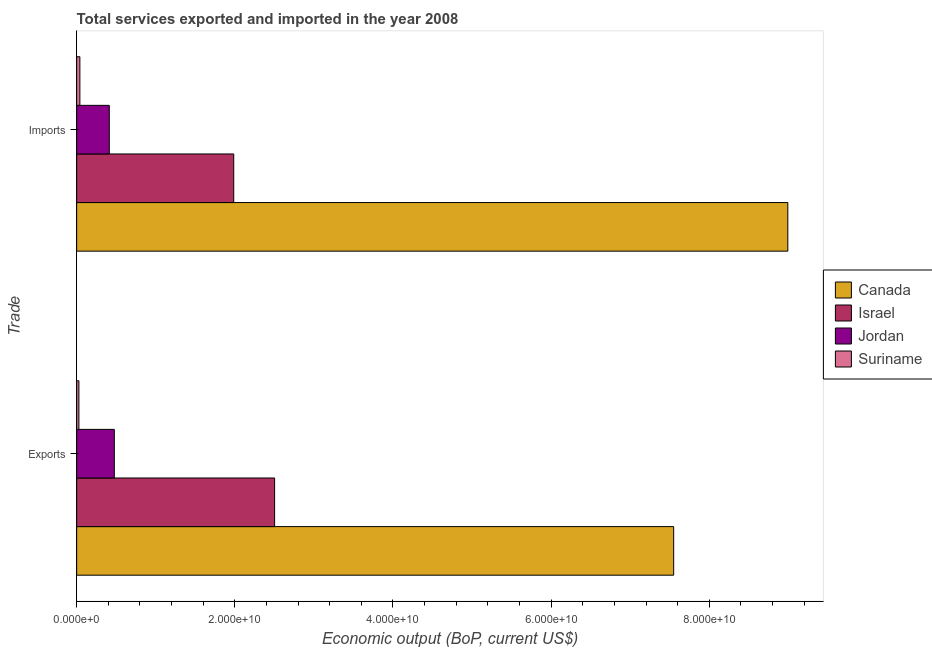How many groups of bars are there?
Provide a succinct answer. 2. Are the number of bars per tick equal to the number of legend labels?
Provide a short and direct response. Yes. Are the number of bars on each tick of the Y-axis equal?
Your response must be concise. Yes. How many bars are there on the 2nd tick from the bottom?
Your answer should be very brief. 4. What is the label of the 2nd group of bars from the top?
Your answer should be compact. Exports. What is the amount of service imports in Israel?
Provide a succinct answer. 1.99e+1. Across all countries, what is the maximum amount of service imports?
Give a very brief answer. 8.99e+1. Across all countries, what is the minimum amount of service exports?
Ensure brevity in your answer.  2.84e+08. In which country was the amount of service exports maximum?
Your answer should be very brief. Canada. In which country was the amount of service exports minimum?
Give a very brief answer. Suriname. What is the total amount of service imports in the graph?
Give a very brief answer. 1.14e+11. What is the difference between the amount of service exports in Israel and that in Jordan?
Offer a terse response. 2.03e+1. What is the difference between the amount of service imports in Canada and the amount of service exports in Jordan?
Make the answer very short. 8.52e+1. What is the average amount of service imports per country?
Provide a succinct answer. 2.86e+1. What is the difference between the amount of service exports and amount of service imports in Suriname?
Ensure brevity in your answer.  -1.23e+08. In how many countries, is the amount of service exports greater than 88000000000 US$?
Ensure brevity in your answer.  0. What is the ratio of the amount of service imports in Israel to that in Suriname?
Your answer should be compact. 48.78. What does the 3rd bar from the bottom in Exports represents?
Provide a succinct answer. Jordan. Are all the bars in the graph horizontal?
Give a very brief answer. Yes. How many countries are there in the graph?
Your answer should be very brief. 4. Are the values on the major ticks of X-axis written in scientific E-notation?
Your answer should be compact. Yes. What is the title of the graph?
Offer a very short reply. Total services exported and imported in the year 2008. What is the label or title of the X-axis?
Your response must be concise. Economic output (BoP, current US$). What is the label or title of the Y-axis?
Give a very brief answer. Trade. What is the Economic output (BoP, current US$) in Canada in Exports?
Your answer should be compact. 7.55e+1. What is the Economic output (BoP, current US$) in Israel in Exports?
Your answer should be compact. 2.50e+1. What is the Economic output (BoP, current US$) in Jordan in Exports?
Your answer should be very brief. 4.76e+09. What is the Economic output (BoP, current US$) in Suriname in Exports?
Ensure brevity in your answer.  2.84e+08. What is the Economic output (BoP, current US$) in Canada in Imports?
Offer a terse response. 8.99e+1. What is the Economic output (BoP, current US$) of Israel in Imports?
Your answer should be compact. 1.99e+1. What is the Economic output (BoP, current US$) in Jordan in Imports?
Your response must be concise. 4.13e+09. What is the Economic output (BoP, current US$) of Suriname in Imports?
Make the answer very short. 4.07e+08. Across all Trade, what is the maximum Economic output (BoP, current US$) of Canada?
Your answer should be compact. 8.99e+1. Across all Trade, what is the maximum Economic output (BoP, current US$) of Israel?
Ensure brevity in your answer.  2.50e+1. Across all Trade, what is the maximum Economic output (BoP, current US$) in Jordan?
Your response must be concise. 4.76e+09. Across all Trade, what is the maximum Economic output (BoP, current US$) of Suriname?
Provide a short and direct response. 4.07e+08. Across all Trade, what is the minimum Economic output (BoP, current US$) of Canada?
Provide a succinct answer. 7.55e+1. Across all Trade, what is the minimum Economic output (BoP, current US$) in Israel?
Offer a terse response. 1.99e+1. Across all Trade, what is the minimum Economic output (BoP, current US$) of Jordan?
Offer a terse response. 4.13e+09. Across all Trade, what is the minimum Economic output (BoP, current US$) of Suriname?
Make the answer very short. 2.84e+08. What is the total Economic output (BoP, current US$) in Canada in the graph?
Ensure brevity in your answer.  1.65e+11. What is the total Economic output (BoP, current US$) of Israel in the graph?
Keep it short and to the point. 4.49e+1. What is the total Economic output (BoP, current US$) in Jordan in the graph?
Give a very brief answer. 8.89e+09. What is the total Economic output (BoP, current US$) in Suriname in the graph?
Provide a short and direct response. 6.91e+08. What is the difference between the Economic output (BoP, current US$) of Canada in Exports and that in Imports?
Keep it short and to the point. -1.44e+1. What is the difference between the Economic output (BoP, current US$) in Israel in Exports and that in Imports?
Ensure brevity in your answer.  5.17e+09. What is the difference between the Economic output (BoP, current US$) in Jordan in Exports and that in Imports?
Your response must be concise. 6.35e+08. What is the difference between the Economic output (BoP, current US$) in Suriname in Exports and that in Imports?
Make the answer very short. -1.23e+08. What is the difference between the Economic output (BoP, current US$) in Canada in Exports and the Economic output (BoP, current US$) in Israel in Imports?
Keep it short and to the point. 5.56e+1. What is the difference between the Economic output (BoP, current US$) of Canada in Exports and the Economic output (BoP, current US$) of Jordan in Imports?
Offer a very short reply. 7.14e+1. What is the difference between the Economic output (BoP, current US$) in Canada in Exports and the Economic output (BoP, current US$) in Suriname in Imports?
Give a very brief answer. 7.51e+1. What is the difference between the Economic output (BoP, current US$) of Israel in Exports and the Economic output (BoP, current US$) of Jordan in Imports?
Give a very brief answer. 2.09e+1. What is the difference between the Economic output (BoP, current US$) of Israel in Exports and the Economic output (BoP, current US$) of Suriname in Imports?
Ensure brevity in your answer.  2.46e+1. What is the difference between the Economic output (BoP, current US$) in Jordan in Exports and the Economic output (BoP, current US$) in Suriname in Imports?
Your answer should be very brief. 4.35e+09. What is the average Economic output (BoP, current US$) in Canada per Trade?
Provide a short and direct response. 8.27e+1. What is the average Economic output (BoP, current US$) in Israel per Trade?
Your answer should be compact. 2.24e+1. What is the average Economic output (BoP, current US$) in Jordan per Trade?
Provide a short and direct response. 4.44e+09. What is the average Economic output (BoP, current US$) in Suriname per Trade?
Your answer should be compact. 3.46e+08. What is the difference between the Economic output (BoP, current US$) in Canada and Economic output (BoP, current US$) in Israel in Exports?
Make the answer very short. 5.05e+1. What is the difference between the Economic output (BoP, current US$) of Canada and Economic output (BoP, current US$) of Jordan in Exports?
Offer a very short reply. 7.07e+1. What is the difference between the Economic output (BoP, current US$) of Canada and Economic output (BoP, current US$) of Suriname in Exports?
Keep it short and to the point. 7.52e+1. What is the difference between the Economic output (BoP, current US$) of Israel and Economic output (BoP, current US$) of Jordan in Exports?
Your response must be concise. 2.03e+1. What is the difference between the Economic output (BoP, current US$) in Israel and Economic output (BoP, current US$) in Suriname in Exports?
Keep it short and to the point. 2.47e+1. What is the difference between the Economic output (BoP, current US$) of Jordan and Economic output (BoP, current US$) of Suriname in Exports?
Provide a short and direct response. 4.48e+09. What is the difference between the Economic output (BoP, current US$) of Canada and Economic output (BoP, current US$) of Israel in Imports?
Give a very brief answer. 7.01e+1. What is the difference between the Economic output (BoP, current US$) of Canada and Economic output (BoP, current US$) of Jordan in Imports?
Offer a terse response. 8.58e+1. What is the difference between the Economic output (BoP, current US$) in Canada and Economic output (BoP, current US$) in Suriname in Imports?
Ensure brevity in your answer.  8.95e+1. What is the difference between the Economic output (BoP, current US$) of Israel and Economic output (BoP, current US$) of Jordan in Imports?
Your answer should be compact. 1.57e+1. What is the difference between the Economic output (BoP, current US$) in Israel and Economic output (BoP, current US$) in Suriname in Imports?
Your answer should be very brief. 1.95e+1. What is the difference between the Economic output (BoP, current US$) in Jordan and Economic output (BoP, current US$) in Suriname in Imports?
Offer a very short reply. 3.72e+09. What is the ratio of the Economic output (BoP, current US$) in Canada in Exports to that in Imports?
Your answer should be compact. 0.84. What is the ratio of the Economic output (BoP, current US$) in Israel in Exports to that in Imports?
Give a very brief answer. 1.26. What is the ratio of the Economic output (BoP, current US$) in Jordan in Exports to that in Imports?
Your response must be concise. 1.15. What is the ratio of the Economic output (BoP, current US$) in Suriname in Exports to that in Imports?
Offer a terse response. 0.7. What is the difference between the highest and the second highest Economic output (BoP, current US$) in Canada?
Give a very brief answer. 1.44e+1. What is the difference between the highest and the second highest Economic output (BoP, current US$) in Israel?
Your answer should be compact. 5.17e+09. What is the difference between the highest and the second highest Economic output (BoP, current US$) in Jordan?
Keep it short and to the point. 6.35e+08. What is the difference between the highest and the second highest Economic output (BoP, current US$) in Suriname?
Make the answer very short. 1.23e+08. What is the difference between the highest and the lowest Economic output (BoP, current US$) of Canada?
Your response must be concise. 1.44e+1. What is the difference between the highest and the lowest Economic output (BoP, current US$) in Israel?
Give a very brief answer. 5.17e+09. What is the difference between the highest and the lowest Economic output (BoP, current US$) in Jordan?
Give a very brief answer. 6.35e+08. What is the difference between the highest and the lowest Economic output (BoP, current US$) in Suriname?
Make the answer very short. 1.23e+08. 